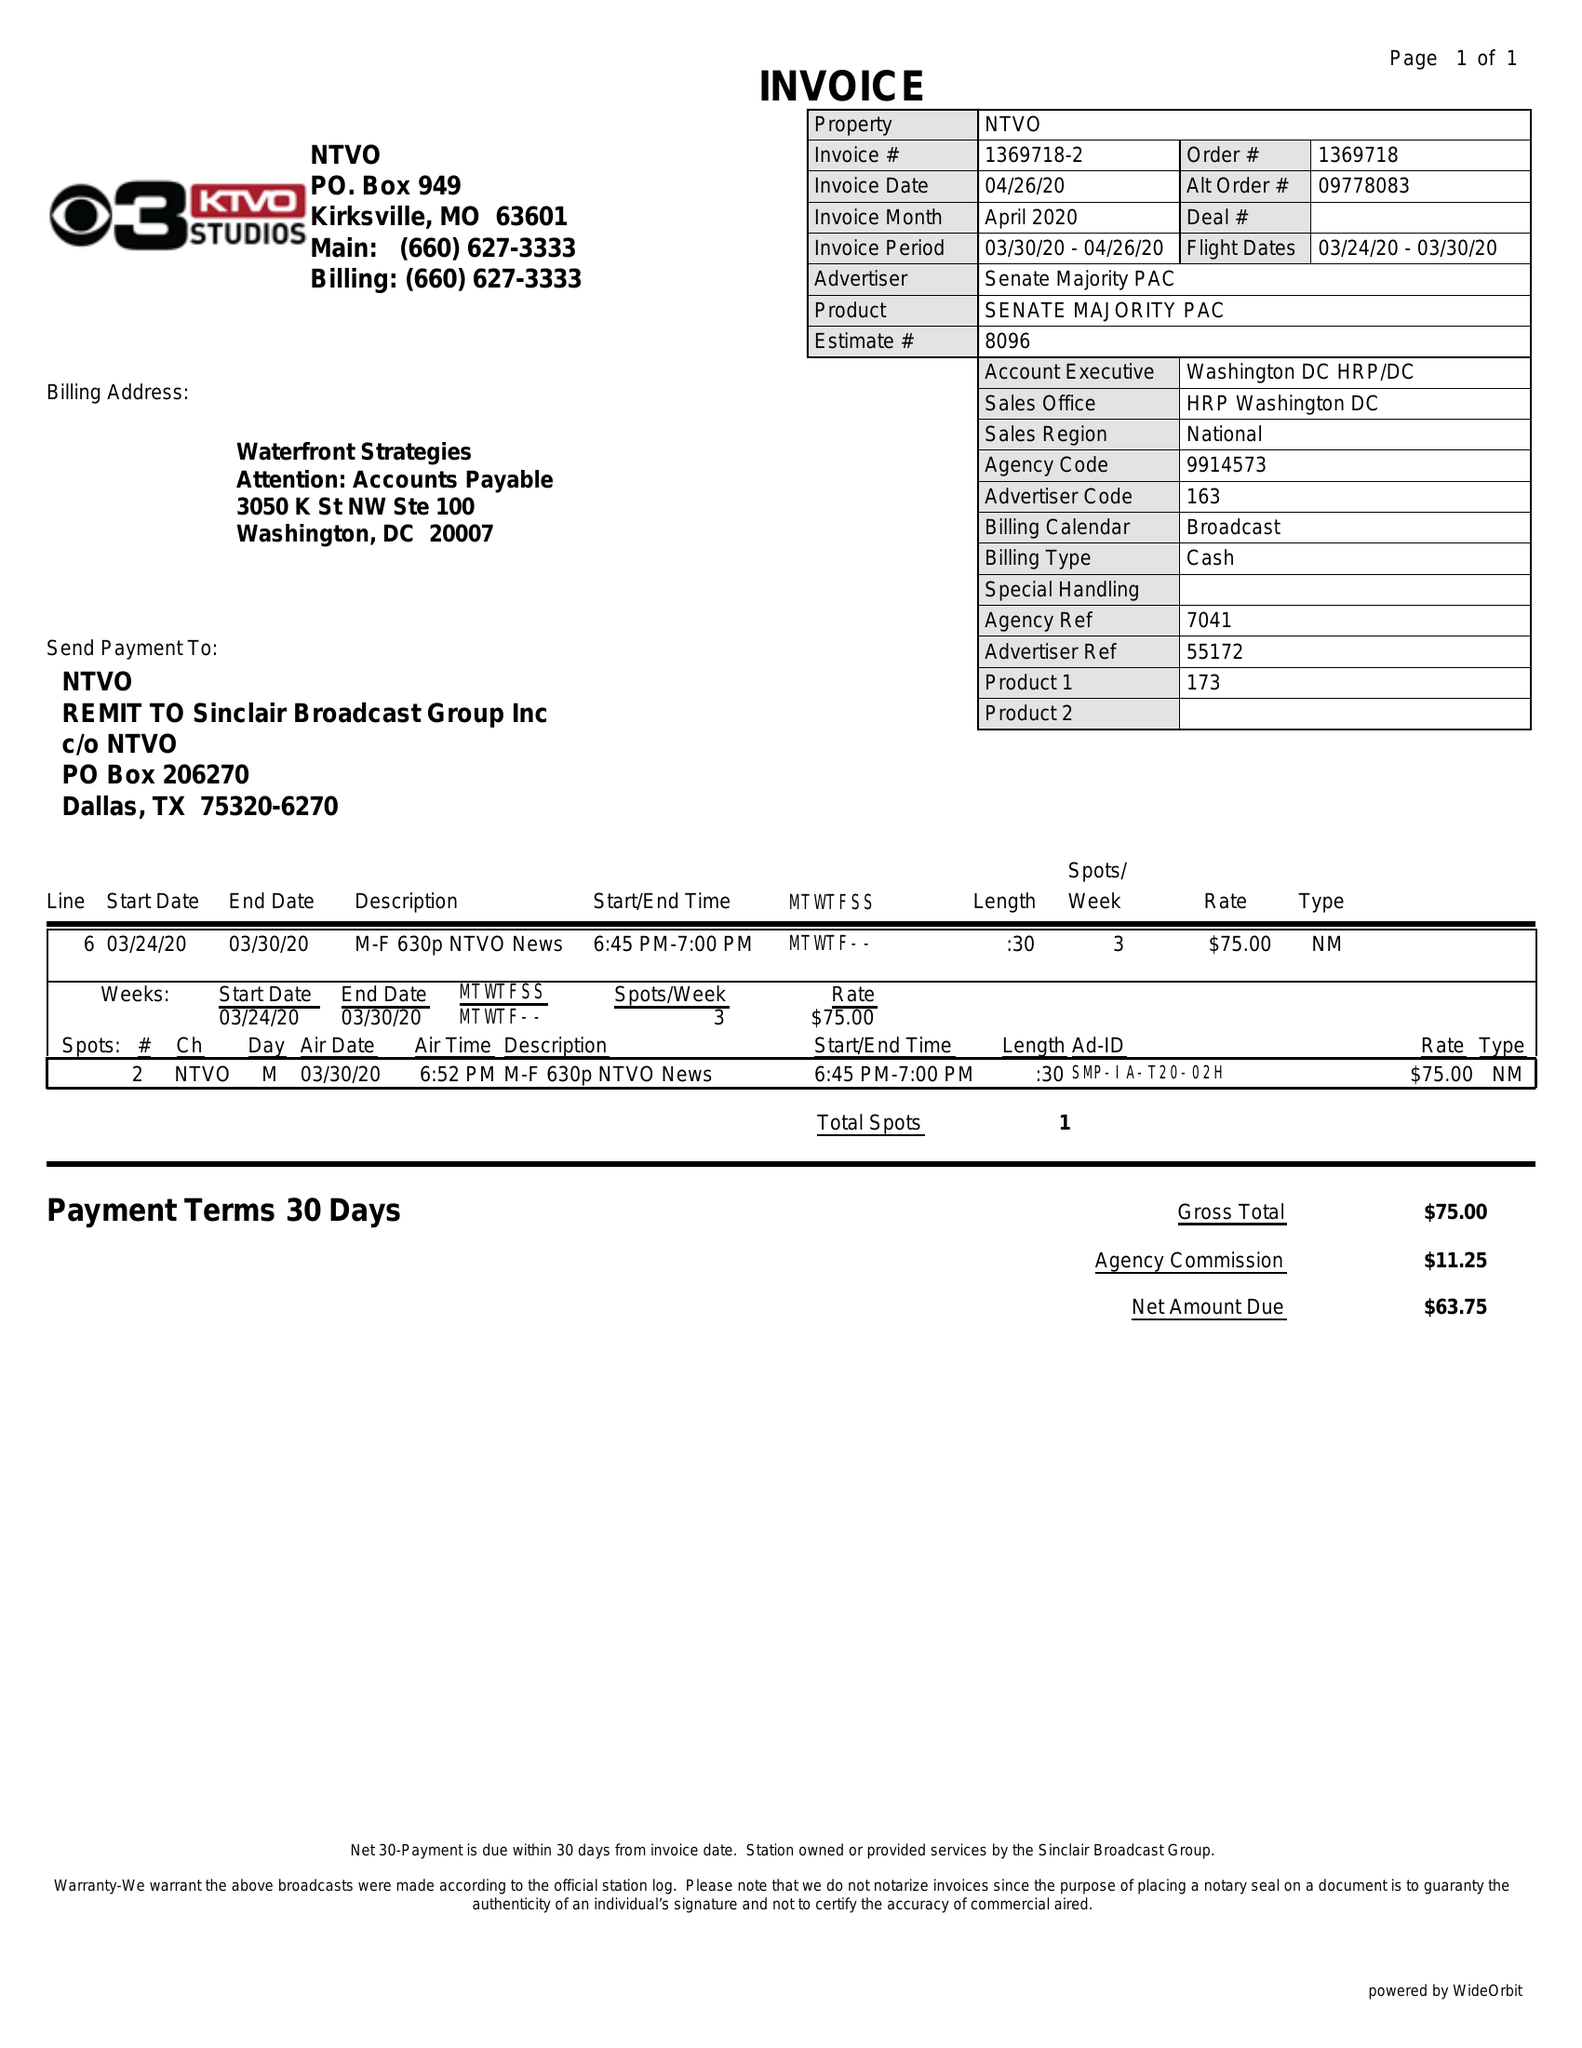What is the value for the flight_from?
Answer the question using a single word or phrase. 03/24/20 